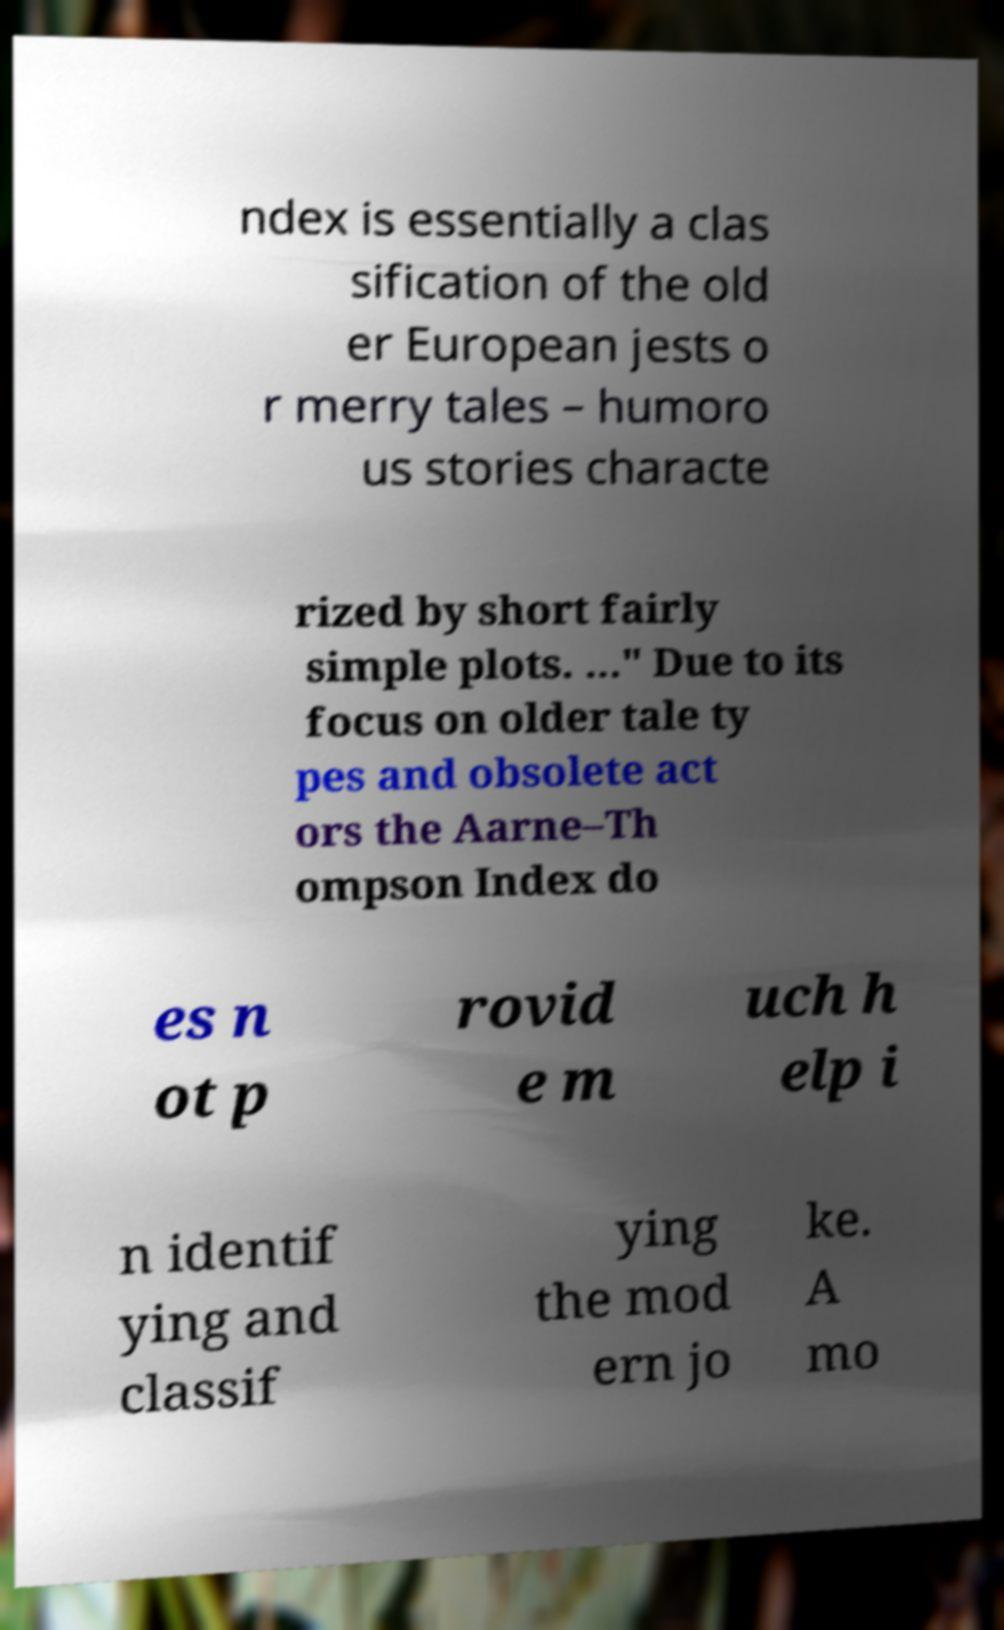I need the written content from this picture converted into text. Can you do that? ndex is essentially a clas sification of the old er European jests o r merry tales – humoro us stories characte rized by short fairly simple plots. …" Due to its focus on older tale ty pes and obsolete act ors the Aarne–Th ompson Index do es n ot p rovid e m uch h elp i n identif ying and classif ying the mod ern jo ke. A mo 